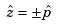<formula> <loc_0><loc_0><loc_500><loc_500>\hat { z } = \pm \hat { p }</formula> 